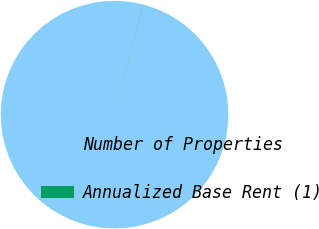<chart> <loc_0><loc_0><loc_500><loc_500><pie_chart><fcel>Number of Properties<fcel>Annualized Base Rent (1)<nl><fcel>99.97%<fcel>0.03%<nl></chart> 